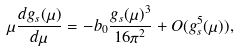<formula> <loc_0><loc_0><loc_500><loc_500>\mu \frac { d g _ { s } ( \mu ) } { d \mu } = - b _ { 0 } \frac { g _ { s } ( \mu ) ^ { 3 } } { 1 6 \pi ^ { 2 } } + O ( g _ { s } ^ { 5 } ( \mu ) ) ,</formula> 